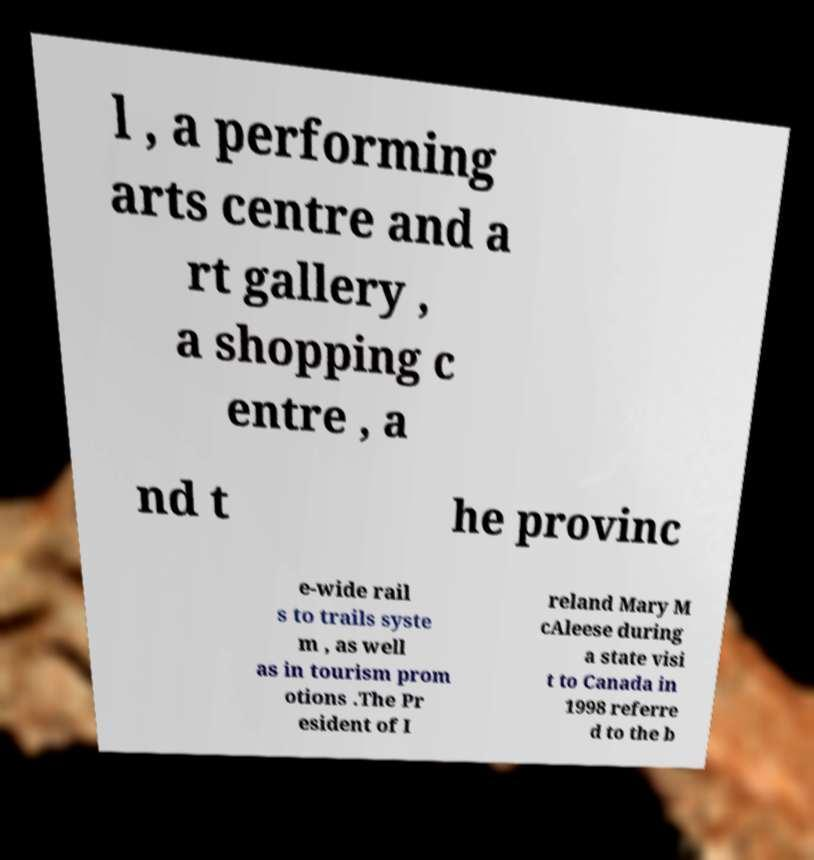Can you read and provide the text displayed in the image?This photo seems to have some interesting text. Can you extract and type it out for me? l , a performing arts centre and a rt gallery , a shopping c entre , a nd t he provinc e-wide rail s to trails syste m , as well as in tourism prom otions .The Pr esident of I reland Mary M cAleese during a state visi t to Canada in 1998 referre d to the b 